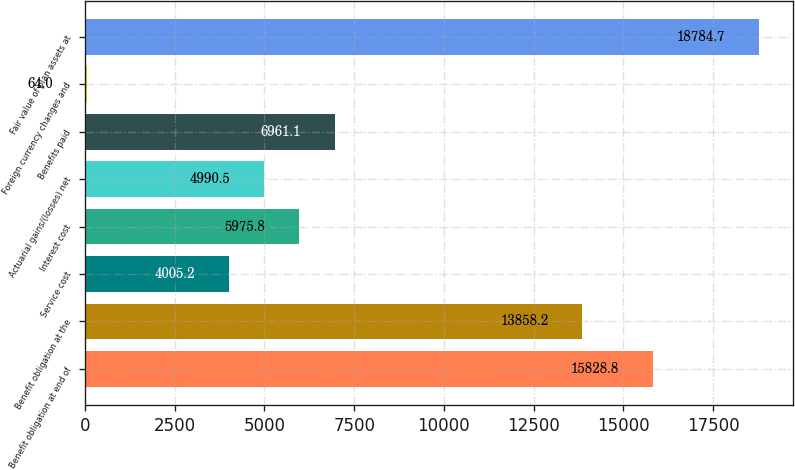<chart> <loc_0><loc_0><loc_500><loc_500><bar_chart><fcel>Benefit obligation at end of<fcel>Benefit obligation at the<fcel>Service cost<fcel>Interest cost<fcel>Actuarial gains/(losses) net<fcel>Benefits paid<fcel>Foreign currency changes and<fcel>Fair value of plan assets at<nl><fcel>15828.8<fcel>13858.2<fcel>4005.2<fcel>5975.8<fcel>4990.5<fcel>6961.1<fcel>64<fcel>18784.7<nl></chart> 